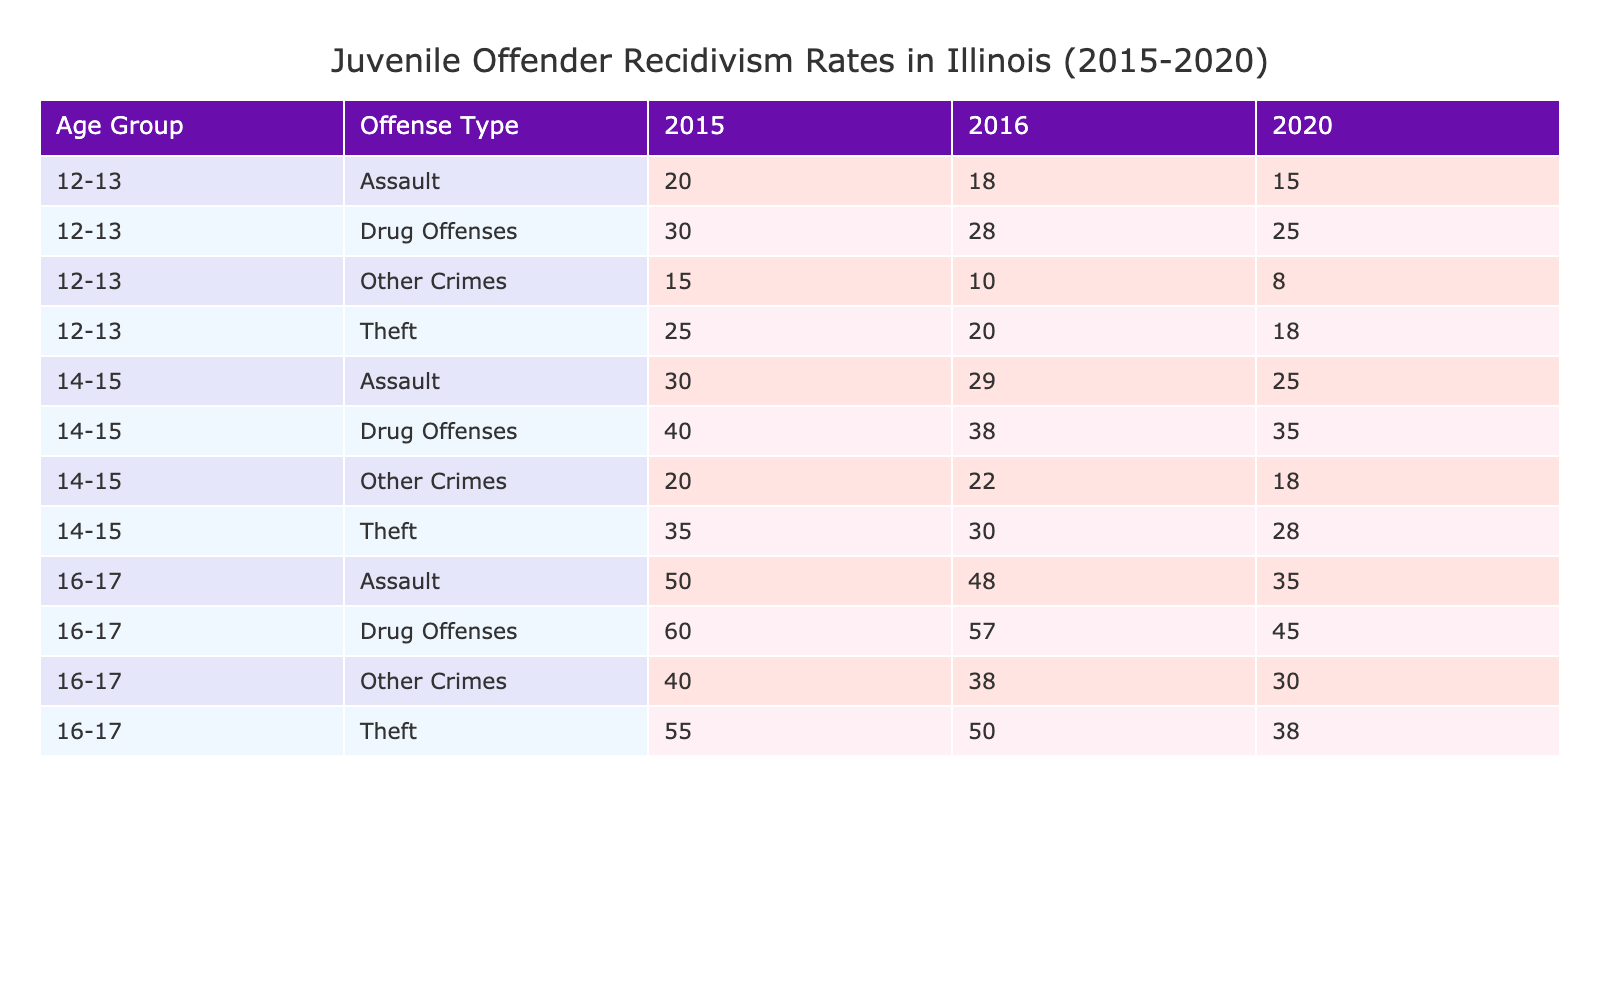What was the recidivism rate for 12-13 year old offenders involved in drug offenses in 2016? According to the table, for the age group 12-13 in the year 2016, the recidivism rate for drug offenses is listed as 28%.
Answer: 28% Which offense type had the highest recidivism rate for 14-15 year old offenders in 2015? In 2015, the recidivism rates for 14-15 year old offenders are as follows: Theft (35%), Assault (30%), Drug Offenses (40%), and Other Crimes (20%). The highest rate among these is for Drug Offenses at 40%.
Answer: Drug Offenses Is the recidivism rate for assault for 16-17 year old offenders higher in 2020 compared to 2015? The assault recidivism rates for 16-17 year old offenders are 50% in 2015 and 35% in 2020. Since 35% < 50%, the rate is not higher in 2020 than in 2015.
Answer: No What is the total recidivism rate for theft offenses across all age groups in 2015? From the table, the recidivism rates for theft in 2015 are: 25% (12-13), 35% (14-15), and 55% (16-17). Adding these gives 25 + 35 + 55 = 115%. Then dividing by 3 for the average rate gives 115/3 = 38.33%.
Answer: 38.33% Did the recidivism rate for drug offenses decrease from 2016 to 2020 for the age group 12-13? For 12-13 year old offenders, the drug offense recidivism rates are 28% in 2016 and 25% in 2020. Since 25% < 28%, it did decrease.
Answer: Yes 